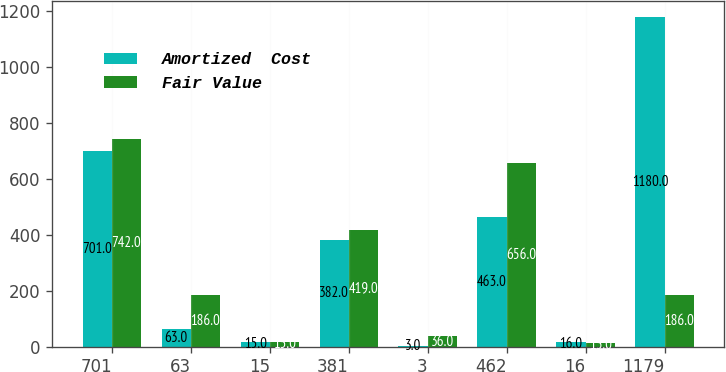<chart> <loc_0><loc_0><loc_500><loc_500><stacked_bar_chart><ecel><fcel>701<fcel>63<fcel>15<fcel>381<fcel>3<fcel>462<fcel>16<fcel>1179<nl><fcel>Amortized  Cost<fcel>701<fcel>63<fcel>15<fcel>382<fcel>3<fcel>463<fcel>16<fcel>1180<nl><fcel>Fair Value<fcel>742<fcel>186<fcel>15<fcel>419<fcel>36<fcel>656<fcel>13<fcel>186<nl></chart> 